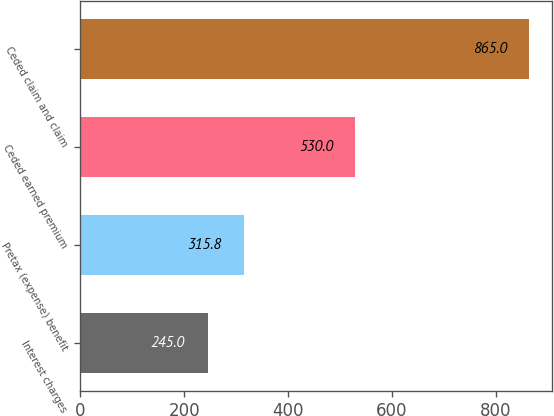Convert chart. <chart><loc_0><loc_0><loc_500><loc_500><bar_chart><fcel>Interest charges<fcel>Pretax (expense) benefit<fcel>Ceded earned premium<fcel>Ceded claim and claim<nl><fcel>245<fcel>315.8<fcel>530<fcel>865<nl></chart> 